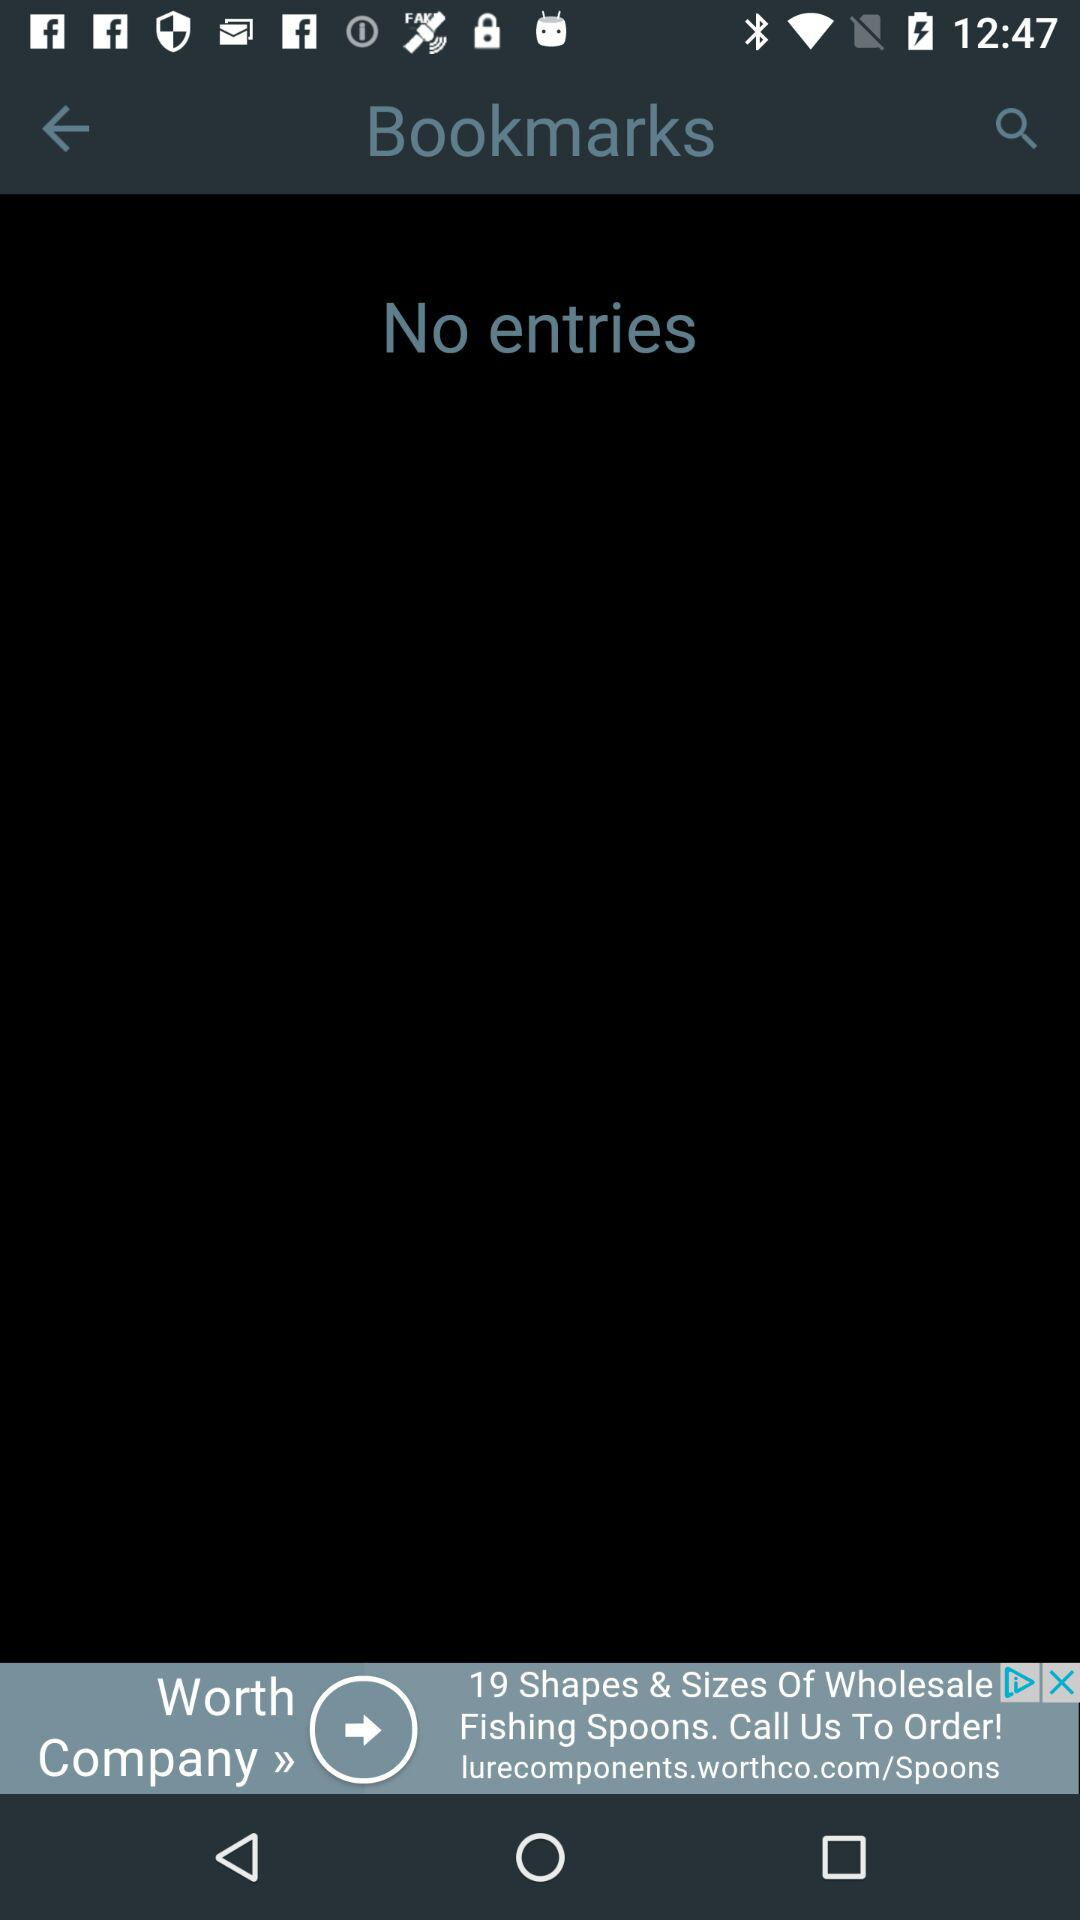How many entries are there? There is no entry. 